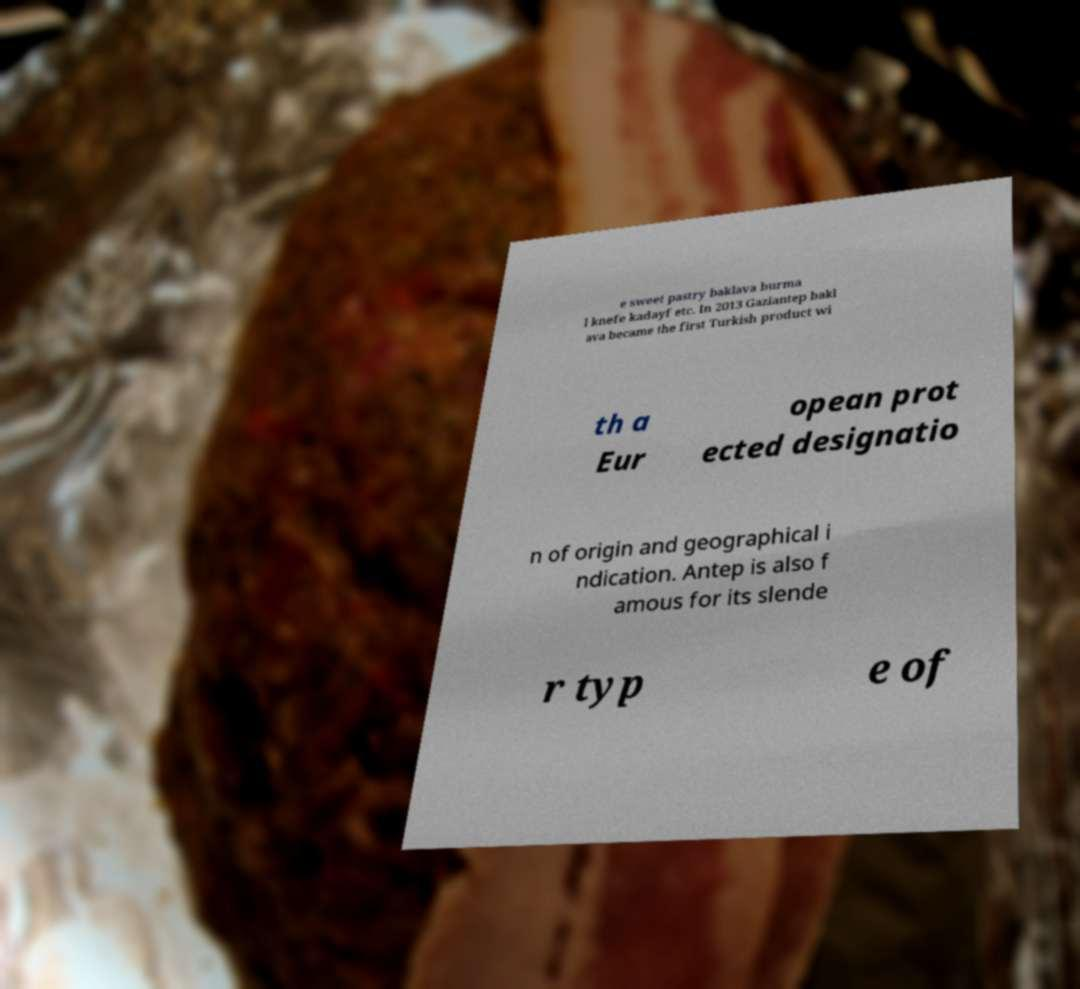Could you extract and type out the text from this image? e sweet pastry baklava burma l knefe kadayf etc. In 2013 Gaziantep bakl ava became the first Turkish product wi th a Eur opean prot ected designatio n of origin and geographical i ndication. Antep is also f amous for its slende r typ e of 